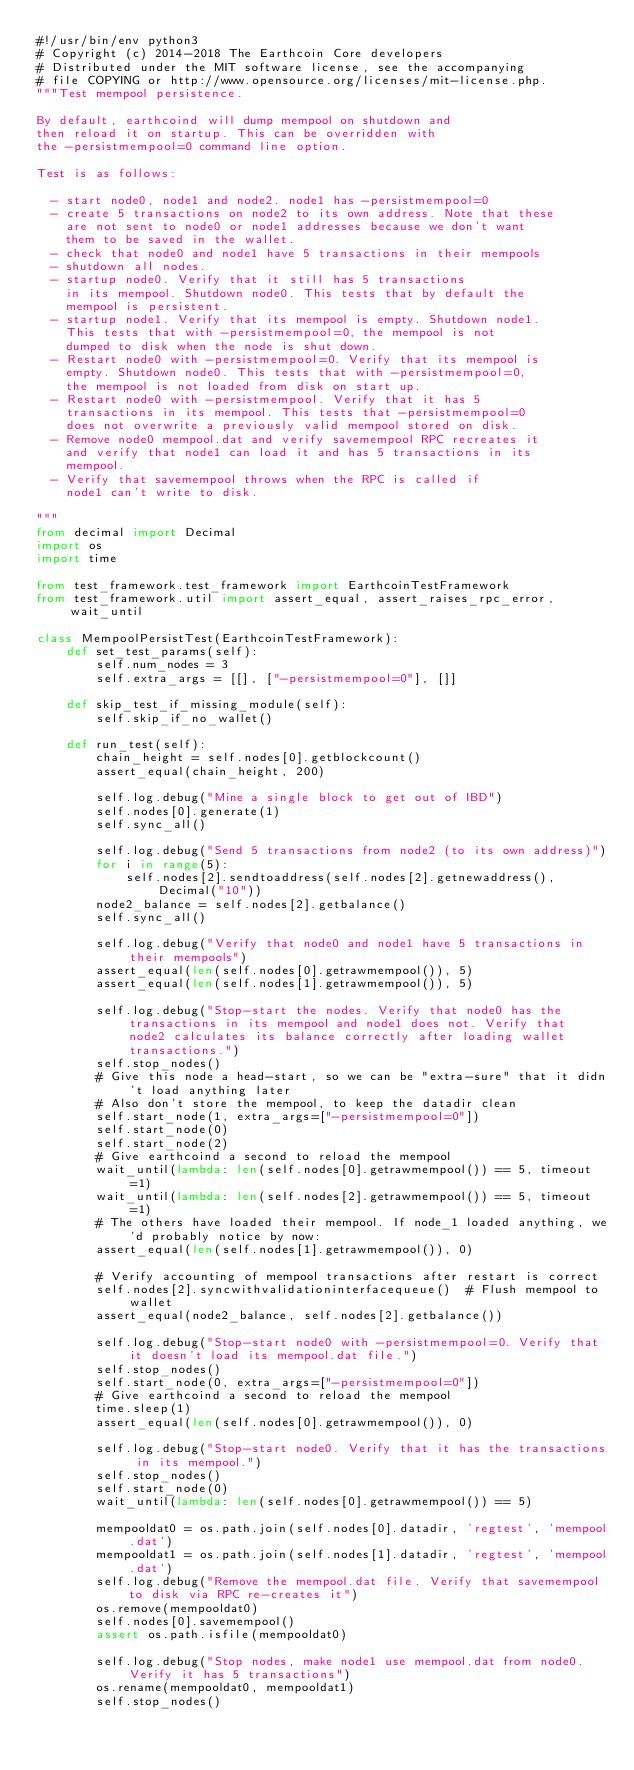<code> <loc_0><loc_0><loc_500><loc_500><_Python_>#!/usr/bin/env python3
# Copyright (c) 2014-2018 The Earthcoin Core developers
# Distributed under the MIT software license, see the accompanying
# file COPYING or http://www.opensource.org/licenses/mit-license.php.
"""Test mempool persistence.

By default, earthcoind will dump mempool on shutdown and
then reload it on startup. This can be overridden with
the -persistmempool=0 command line option.

Test is as follows:

  - start node0, node1 and node2. node1 has -persistmempool=0
  - create 5 transactions on node2 to its own address. Note that these
    are not sent to node0 or node1 addresses because we don't want
    them to be saved in the wallet.
  - check that node0 and node1 have 5 transactions in their mempools
  - shutdown all nodes.
  - startup node0. Verify that it still has 5 transactions
    in its mempool. Shutdown node0. This tests that by default the
    mempool is persistent.
  - startup node1. Verify that its mempool is empty. Shutdown node1.
    This tests that with -persistmempool=0, the mempool is not
    dumped to disk when the node is shut down.
  - Restart node0 with -persistmempool=0. Verify that its mempool is
    empty. Shutdown node0. This tests that with -persistmempool=0,
    the mempool is not loaded from disk on start up.
  - Restart node0 with -persistmempool. Verify that it has 5
    transactions in its mempool. This tests that -persistmempool=0
    does not overwrite a previously valid mempool stored on disk.
  - Remove node0 mempool.dat and verify savemempool RPC recreates it
    and verify that node1 can load it and has 5 transactions in its
    mempool.
  - Verify that savemempool throws when the RPC is called if
    node1 can't write to disk.

"""
from decimal import Decimal
import os
import time

from test_framework.test_framework import EarthcoinTestFramework
from test_framework.util import assert_equal, assert_raises_rpc_error, wait_until

class MempoolPersistTest(EarthcoinTestFramework):
    def set_test_params(self):
        self.num_nodes = 3
        self.extra_args = [[], ["-persistmempool=0"], []]

    def skip_test_if_missing_module(self):
        self.skip_if_no_wallet()

    def run_test(self):
        chain_height = self.nodes[0].getblockcount()
        assert_equal(chain_height, 200)

        self.log.debug("Mine a single block to get out of IBD")
        self.nodes[0].generate(1)
        self.sync_all()

        self.log.debug("Send 5 transactions from node2 (to its own address)")
        for i in range(5):
            self.nodes[2].sendtoaddress(self.nodes[2].getnewaddress(), Decimal("10"))
        node2_balance = self.nodes[2].getbalance()
        self.sync_all()

        self.log.debug("Verify that node0 and node1 have 5 transactions in their mempools")
        assert_equal(len(self.nodes[0].getrawmempool()), 5)
        assert_equal(len(self.nodes[1].getrawmempool()), 5)

        self.log.debug("Stop-start the nodes. Verify that node0 has the transactions in its mempool and node1 does not. Verify that node2 calculates its balance correctly after loading wallet transactions.")
        self.stop_nodes()
        # Give this node a head-start, so we can be "extra-sure" that it didn't load anything later
        # Also don't store the mempool, to keep the datadir clean
        self.start_node(1, extra_args=["-persistmempool=0"])
        self.start_node(0)
        self.start_node(2)
        # Give earthcoind a second to reload the mempool
        wait_until(lambda: len(self.nodes[0].getrawmempool()) == 5, timeout=1)
        wait_until(lambda: len(self.nodes[2].getrawmempool()) == 5, timeout=1)
        # The others have loaded their mempool. If node_1 loaded anything, we'd probably notice by now:
        assert_equal(len(self.nodes[1].getrawmempool()), 0)

        # Verify accounting of mempool transactions after restart is correct
        self.nodes[2].syncwithvalidationinterfacequeue()  # Flush mempool to wallet
        assert_equal(node2_balance, self.nodes[2].getbalance())

        self.log.debug("Stop-start node0 with -persistmempool=0. Verify that it doesn't load its mempool.dat file.")
        self.stop_nodes()
        self.start_node(0, extra_args=["-persistmempool=0"])
        # Give earthcoind a second to reload the mempool
        time.sleep(1)
        assert_equal(len(self.nodes[0].getrawmempool()), 0)

        self.log.debug("Stop-start node0. Verify that it has the transactions in its mempool.")
        self.stop_nodes()
        self.start_node(0)
        wait_until(lambda: len(self.nodes[0].getrawmempool()) == 5)

        mempooldat0 = os.path.join(self.nodes[0].datadir, 'regtest', 'mempool.dat')
        mempooldat1 = os.path.join(self.nodes[1].datadir, 'regtest', 'mempool.dat')
        self.log.debug("Remove the mempool.dat file. Verify that savemempool to disk via RPC re-creates it")
        os.remove(mempooldat0)
        self.nodes[0].savemempool()
        assert os.path.isfile(mempooldat0)

        self.log.debug("Stop nodes, make node1 use mempool.dat from node0. Verify it has 5 transactions")
        os.rename(mempooldat0, mempooldat1)
        self.stop_nodes()</code> 